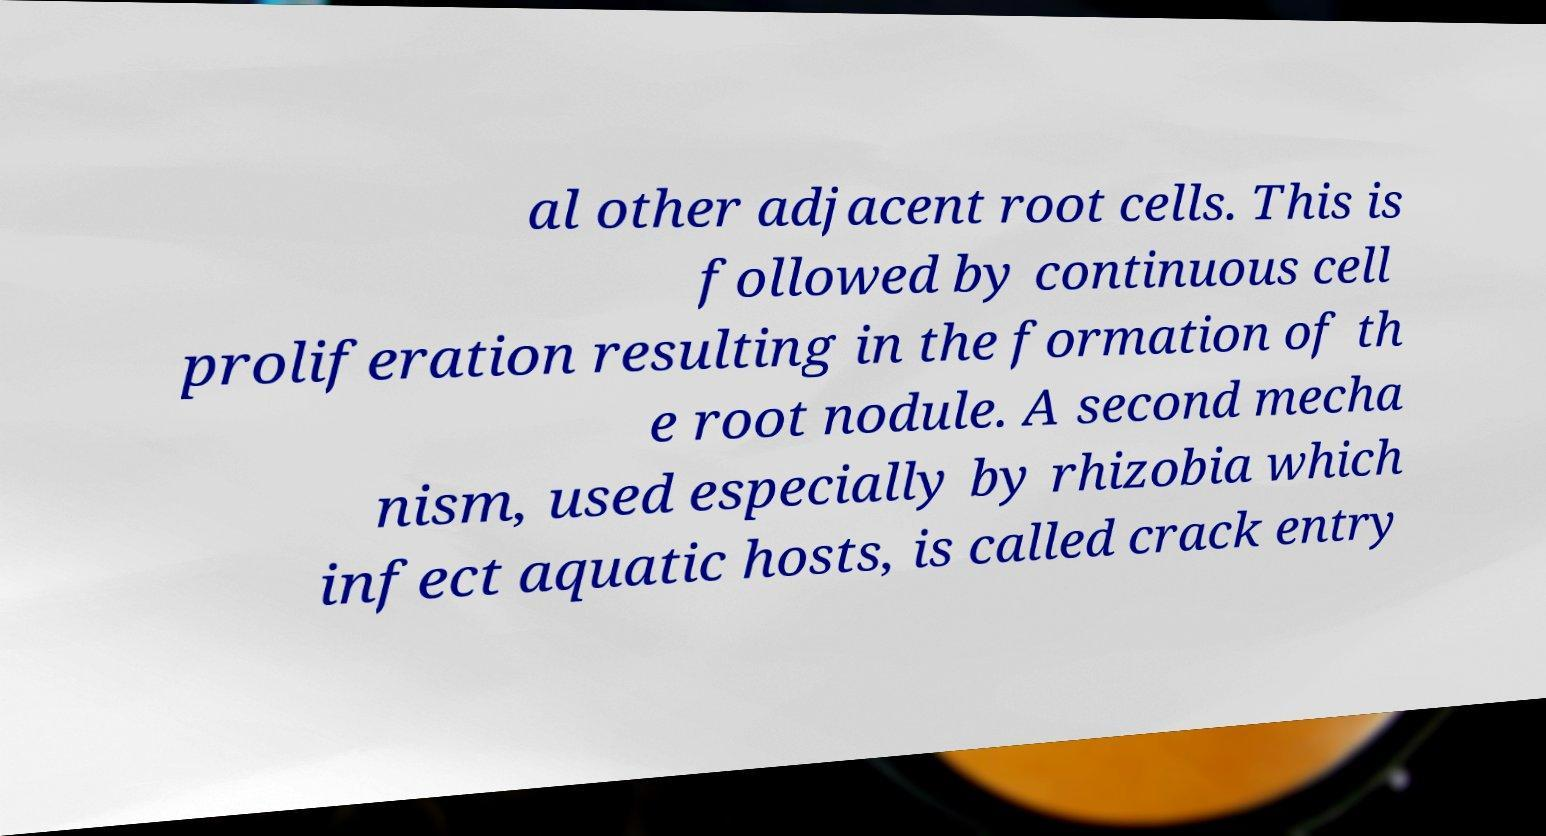Can you accurately transcribe the text from the provided image for me? al other adjacent root cells. This is followed by continuous cell proliferation resulting in the formation of th e root nodule. A second mecha nism, used especially by rhizobia which infect aquatic hosts, is called crack entry 